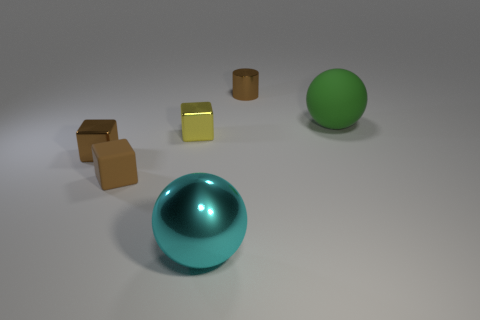Are there fewer cubes than large yellow shiny spheres?
Offer a terse response. No. Are there any small metallic objects that have the same color as the small rubber block?
Ensure brevity in your answer.  Yes. There is a metallic object that is both on the right side of the small yellow cube and behind the matte block; what shape is it?
Provide a short and direct response. Cylinder. What shape is the thing that is right of the metal object right of the cyan ball?
Your response must be concise. Sphere. Is the shape of the green rubber thing the same as the cyan object?
Make the answer very short. Yes. Is the tiny rubber thing the same color as the cylinder?
Offer a terse response. Yes. There is a metal block in front of the yellow cube that is left of the green rubber object; what number of metal things are behind it?
Ensure brevity in your answer.  2. The brown object that is the same material as the brown cylinder is what shape?
Offer a very short reply. Cube. What material is the large thing behind the yellow cube that is behind the rubber object that is in front of the green matte thing?
Provide a short and direct response. Rubber. How many objects are either matte objects that are in front of the big rubber object or brown metallic blocks?
Keep it short and to the point. 2. 